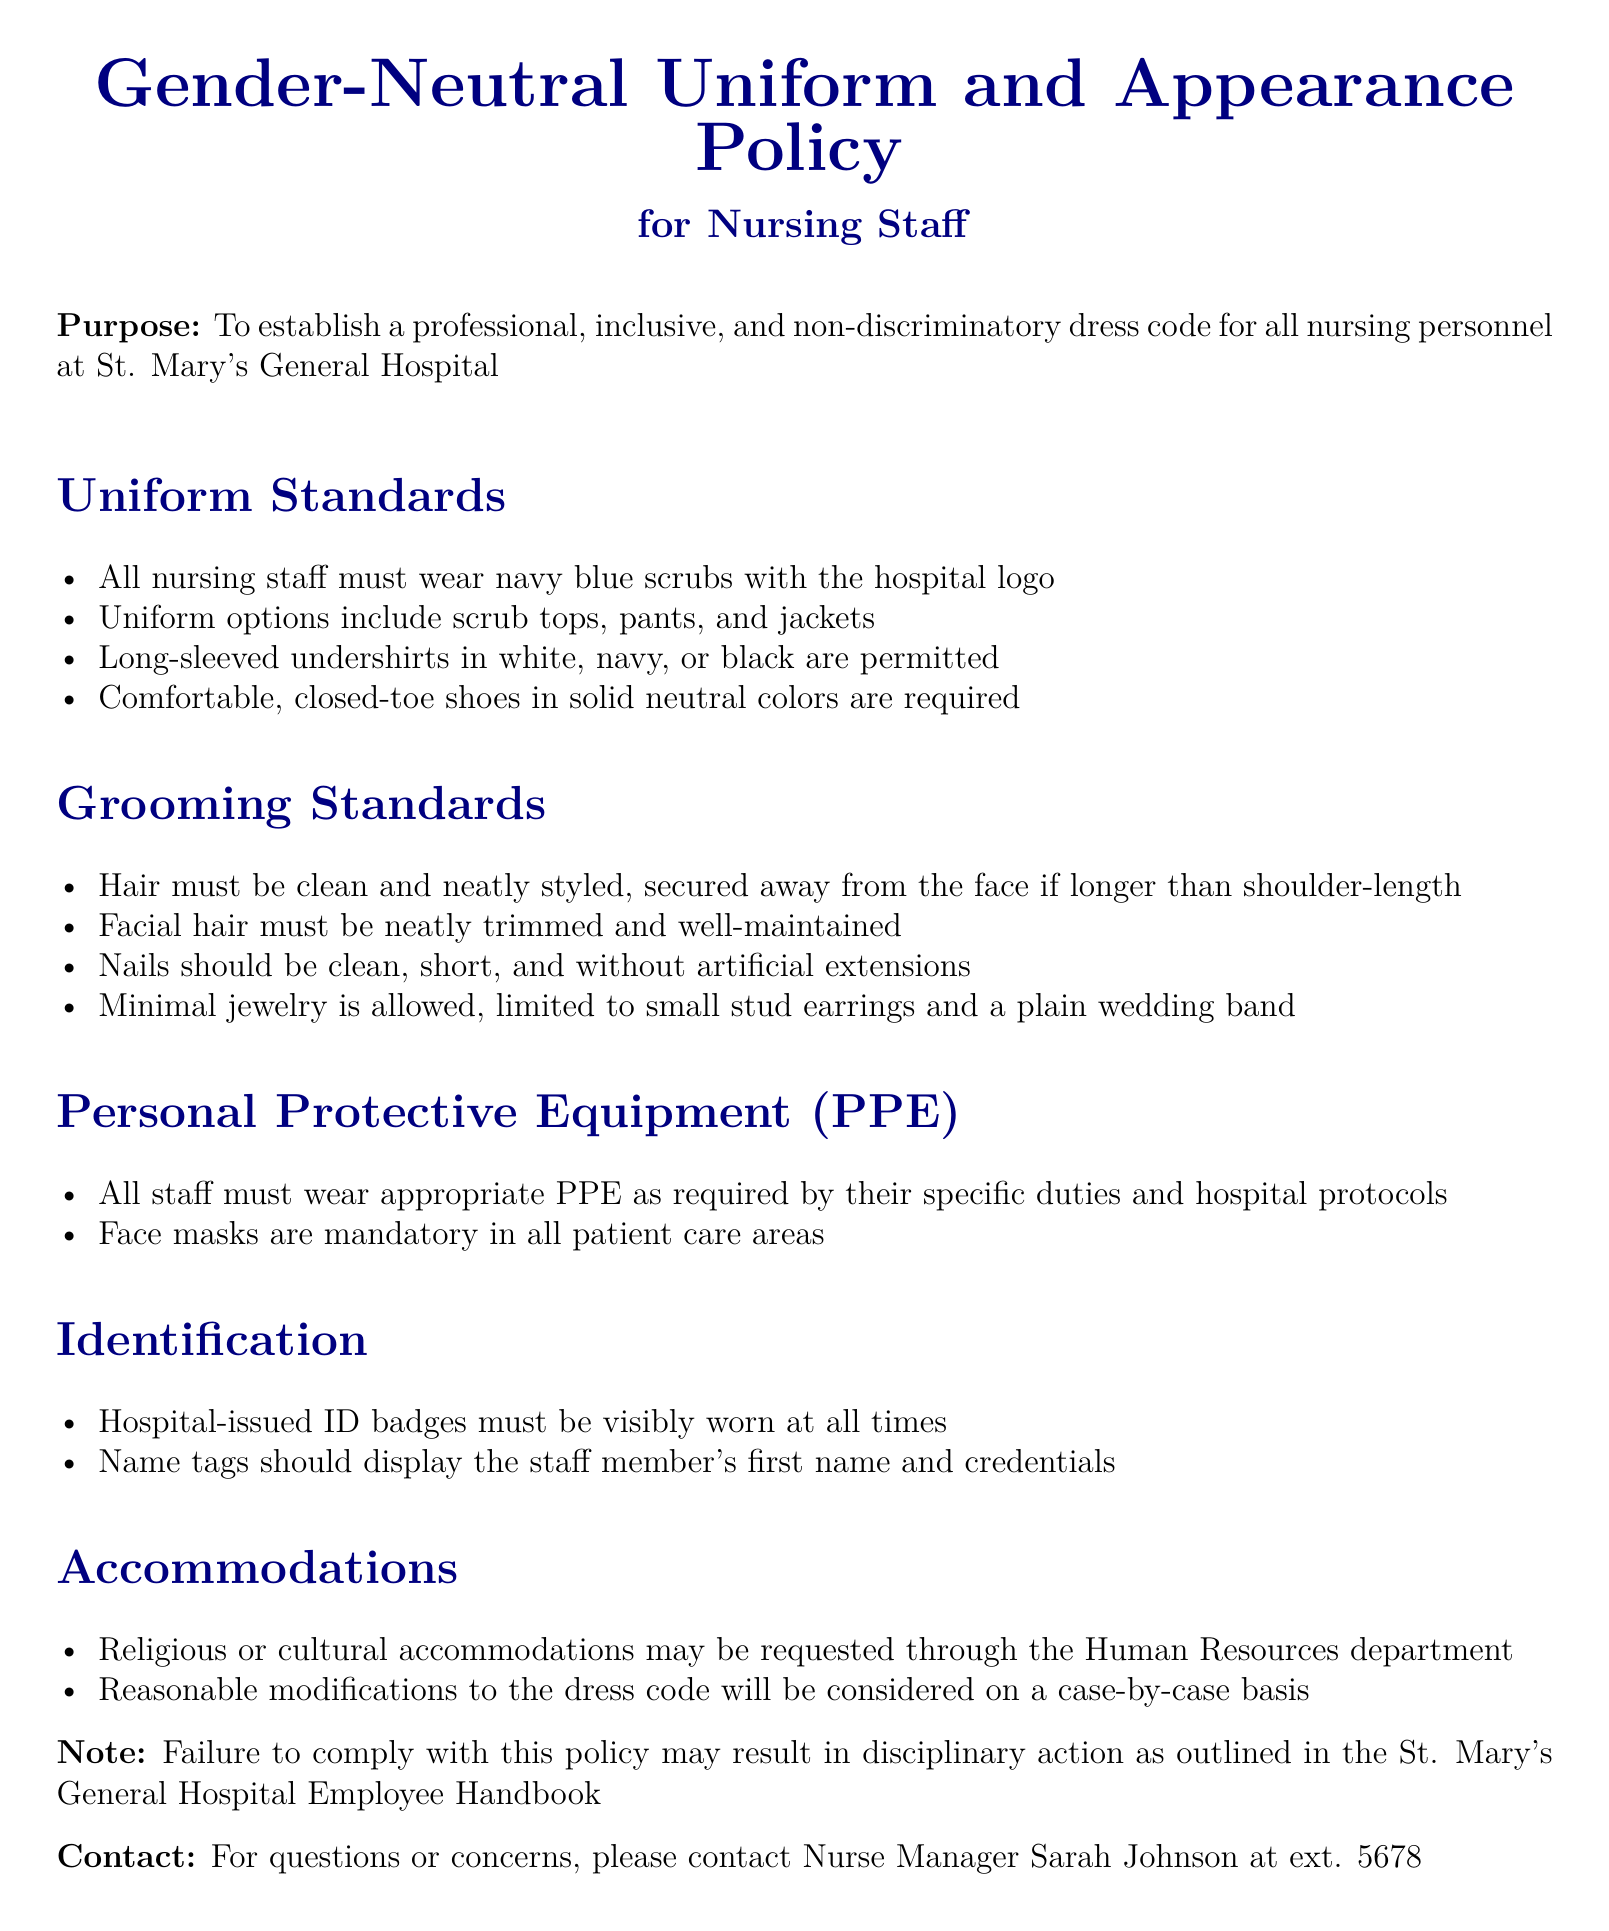What is the purpose of the policy? The purpose is to establish a professional, inclusive, and non-discriminatory dress code for all nursing personnel at St. Mary's General Hospital.
Answer: To establish a professional, inclusive, and non-discriminatory dress code What color are the required scrubs? The document states that all nursing staff must wear navy blue scrubs.
Answer: navy blue What is the maximum type of jewelry allowed? The grooming standards specify that minimal jewelry is allowed, limited to small stud earrings and a plain wedding band.
Answer: small stud earrings and a plain wedding band Who should be contacted for questions or concerns? The document lists Nurse Manager Sarah Johnson as the contact for questions or concerns.
Answer: Nurse Manager Sarah Johnson What must be securely worn at all times? The document mentions that hospital-issued ID badges must be visibly worn at all times.
Answer: hospital-issued ID badges What accommodations may be requested? The policy allows for religious or cultural accommodations to be requested through the Human Resources department.
Answer: religious or cultural accommodations What must staff wear in patient care areas? The policy indicates that face masks are mandatory in all patient care areas.
Answer: face masks What happens if someone fails to comply with the policy? The document states that failure to comply with the policy may result in disciplinary action.
Answer: disciplinary action 